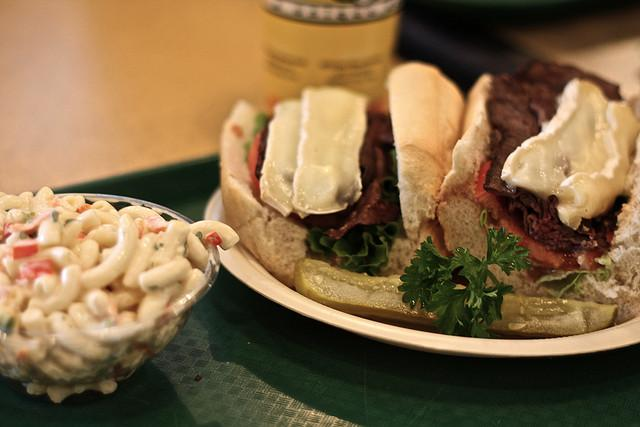What kind of pasta is on the left? macaroni 